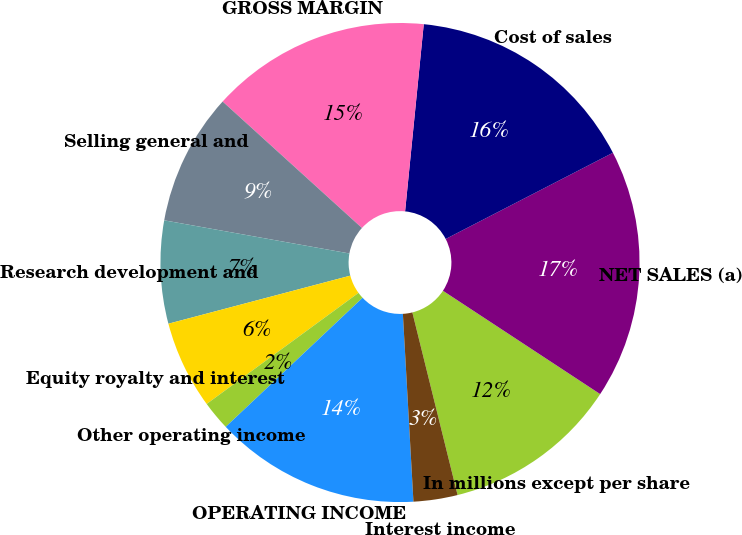<chart> <loc_0><loc_0><loc_500><loc_500><pie_chart><fcel>In millions except per share<fcel>NET SALES (a)<fcel>Cost of sales<fcel>GROSS MARGIN<fcel>Selling general and<fcel>Research development and<fcel>Equity royalty and interest<fcel>Other operating income<fcel>OPERATING INCOME<fcel>Interest income<nl><fcel>11.88%<fcel>16.83%<fcel>15.84%<fcel>14.85%<fcel>8.91%<fcel>6.93%<fcel>5.94%<fcel>1.98%<fcel>13.86%<fcel>2.97%<nl></chart> 